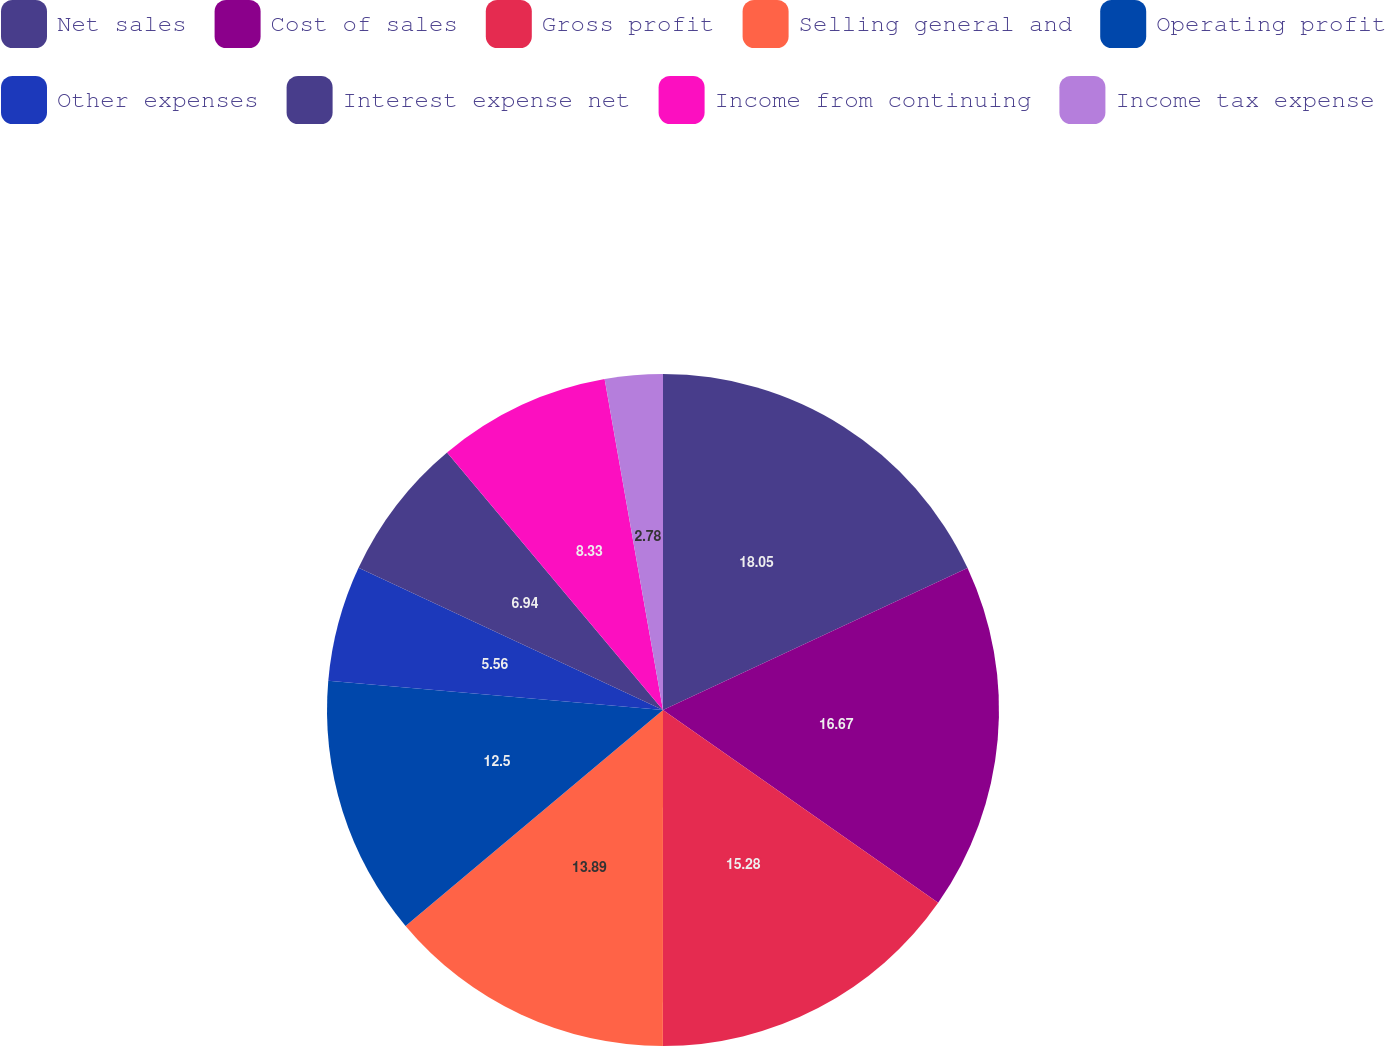<chart> <loc_0><loc_0><loc_500><loc_500><pie_chart><fcel>Net sales<fcel>Cost of sales<fcel>Gross profit<fcel>Selling general and<fcel>Operating profit<fcel>Other expenses<fcel>Interest expense net<fcel>Income from continuing<fcel>Income tax expense<nl><fcel>18.06%<fcel>16.67%<fcel>15.28%<fcel>13.89%<fcel>12.5%<fcel>5.56%<fcel>6.94%<fcel>8.33%<fcel>2.78%<nl></chart> 